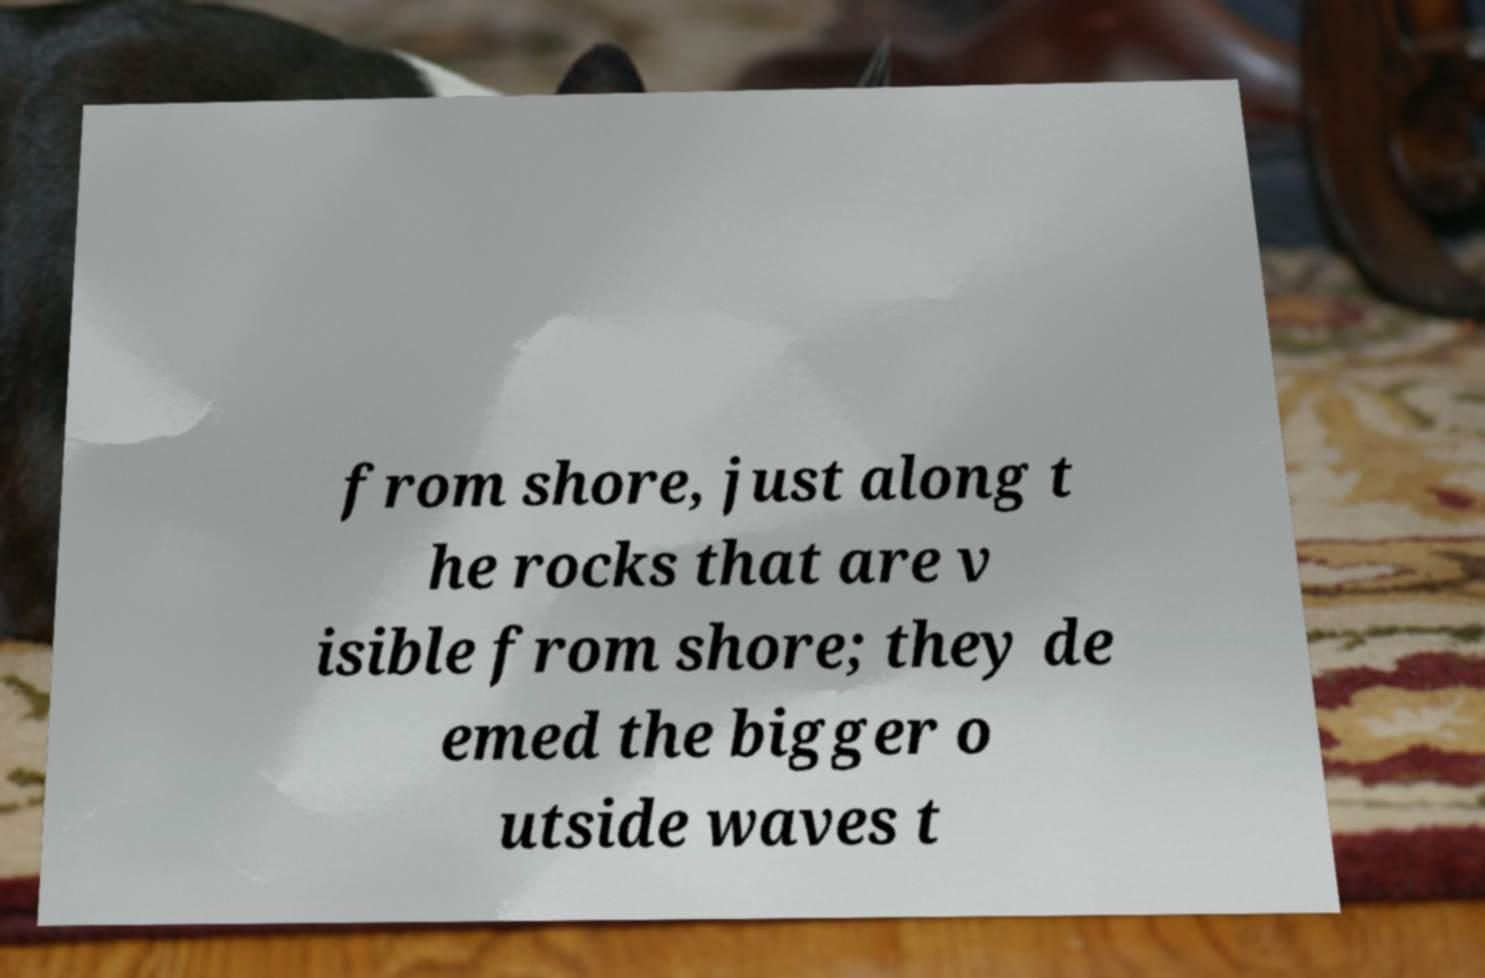For documentation purposes, I need the text within this image transcribed. Could you provide that? from shore, just along t he rocks that are v isible from shore; they de emed the bigger o utside waves t 